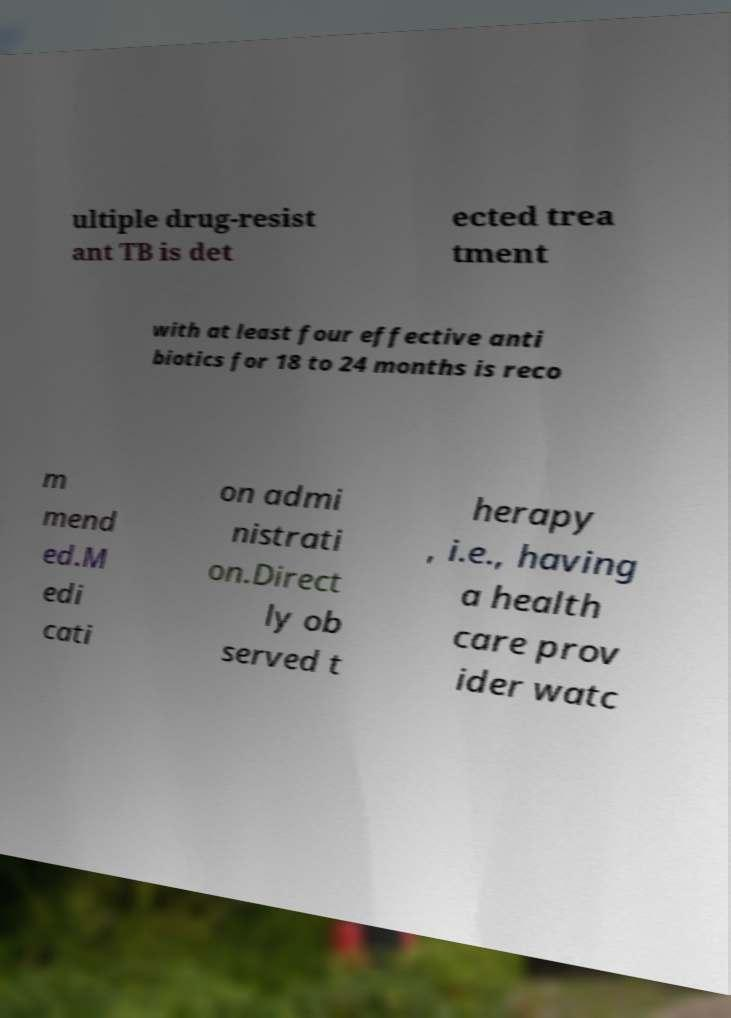Can you accurately transcribe the text from the provided image for me? ultiple drug-resist ant TB is det ected trea tment with at least four effective anti biotics for 18 to 24 months is reco m mend ed.M edi cati on admi nistrati on.Direct ly ob served t herapy , i.e., having a health care prov ider watc 